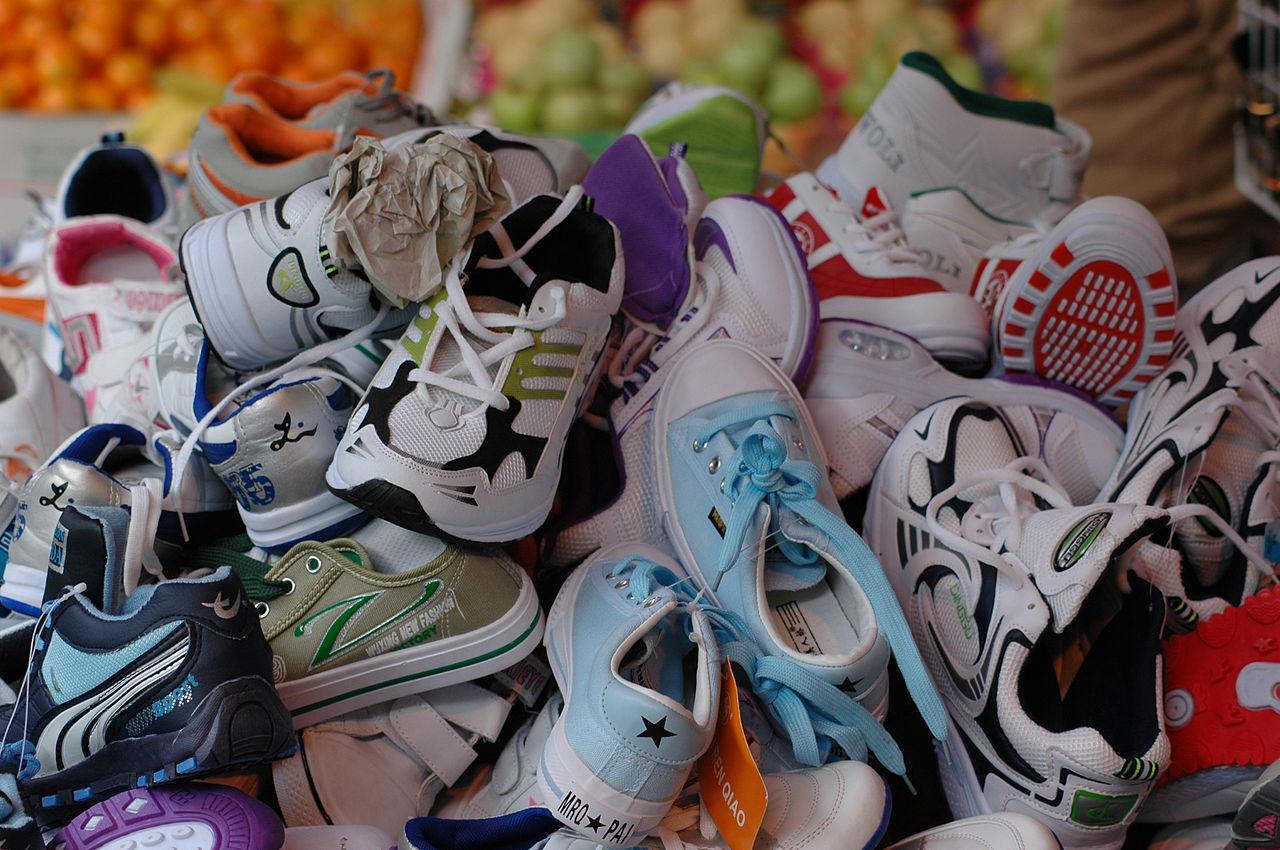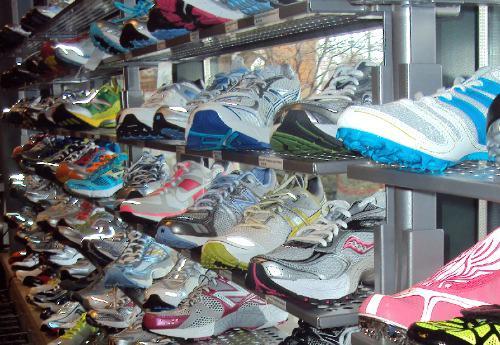The first image is the image on the left, the second image is the image on the right. For the images shown, is this caption "One image contains a single, mostly blue shoe, and the other image shows a pair of shoes, one with its sole turned to the camera." true? Answer yes or no. No. The first image is the image on the left, the second image is the image on the right. Examine the images to the left and right. Is the description "The right image contains exactly one blue sports tennis shoe." accurate? Answer yes or no. No. 